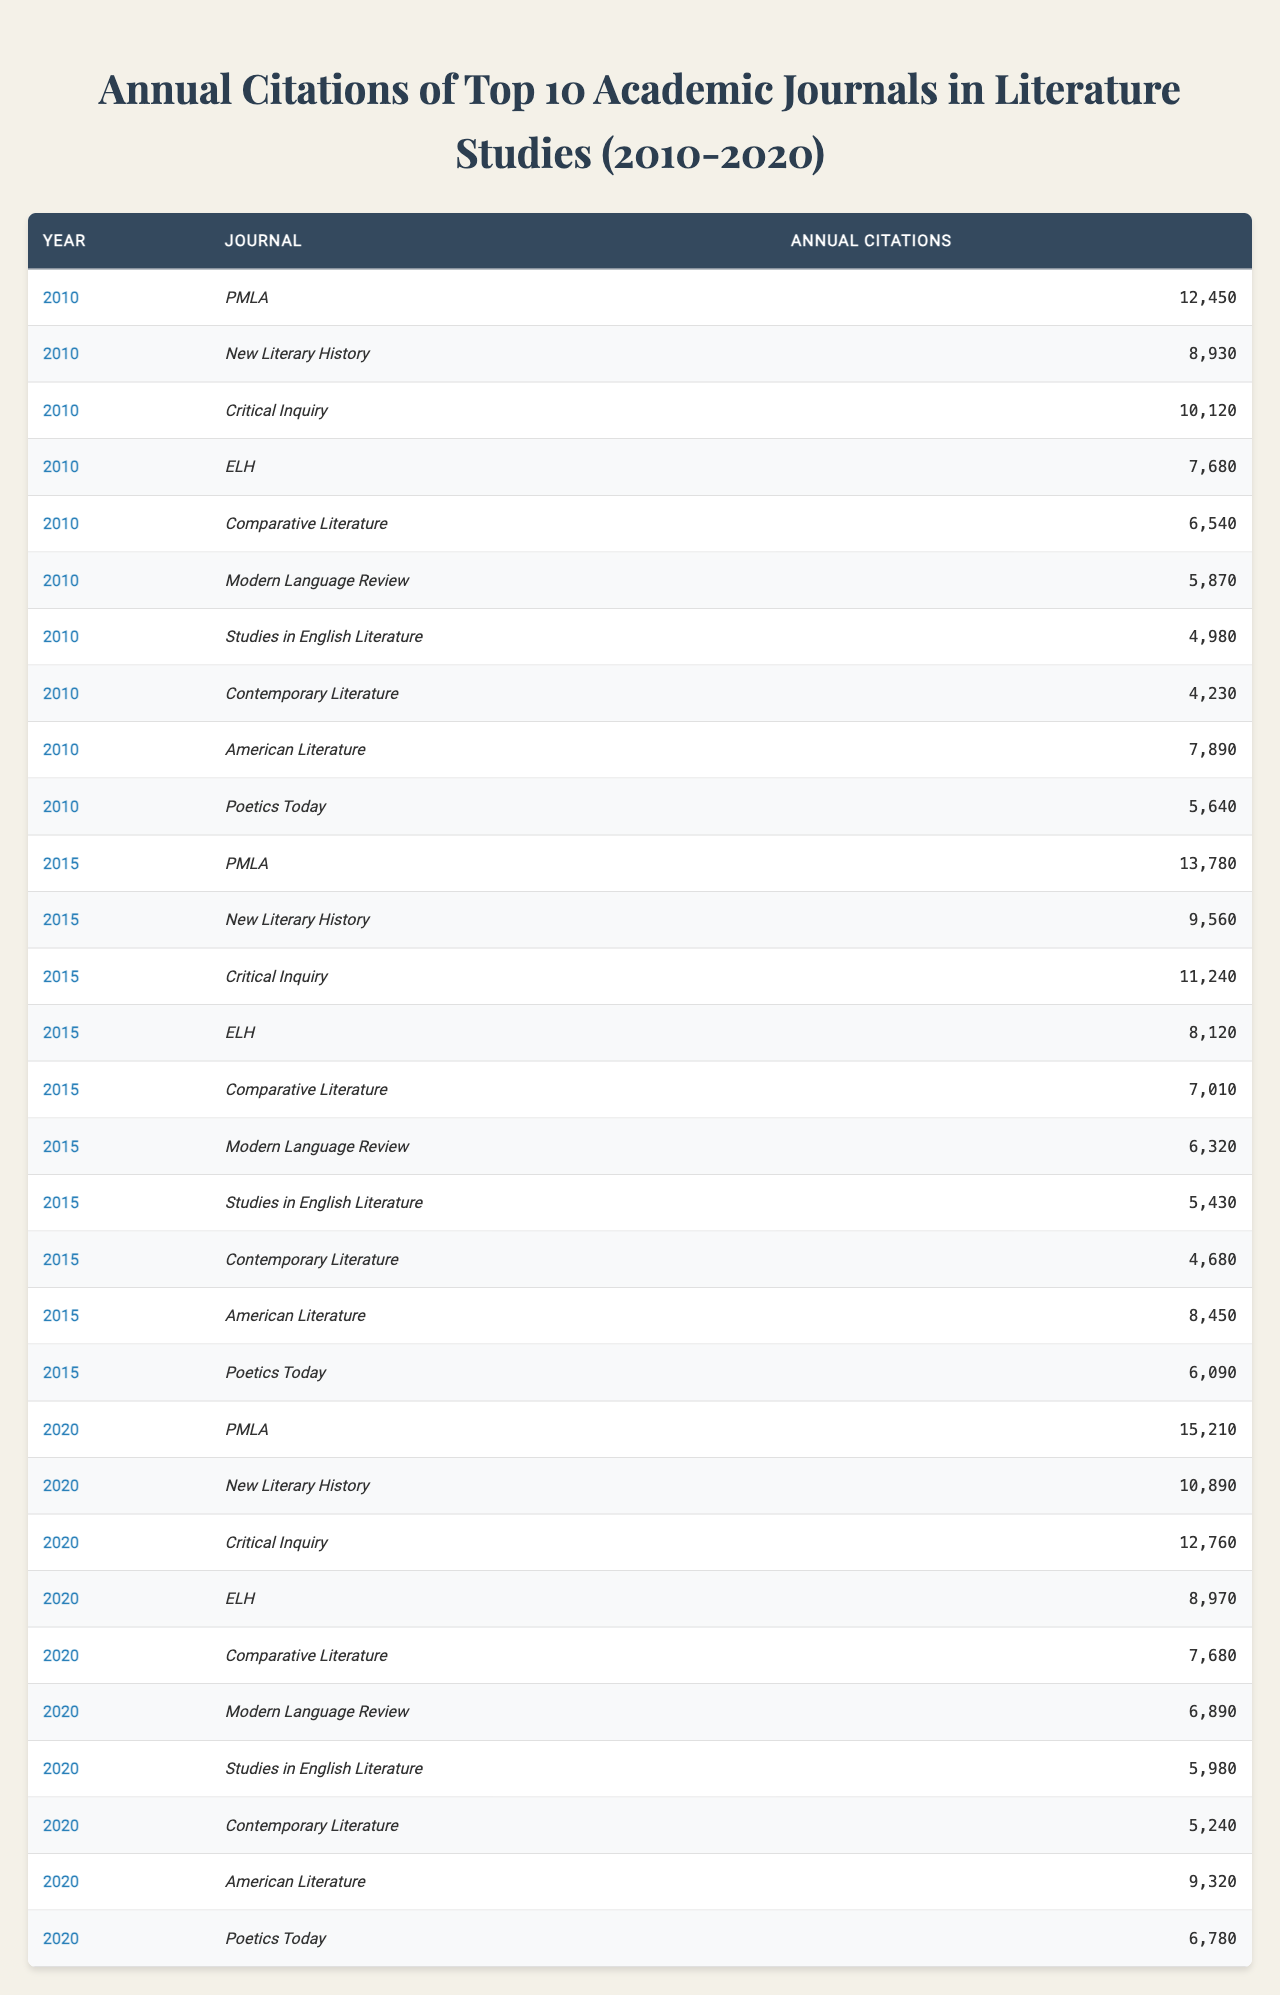What was the highest annual citation for "PMLA" in the years provided? In the years 2010, 2015, and 2020, the citations for "PMLA" were 12450, 13780, and 15210 respectively. The highest citation among these is 15210 in 2020.
Answer: 15210 Which journal had the lowest citations in 2010? Looking at the citations for the journals in 2010, "Contemporary Literature" had the lowest citation count with 4230.
Answer: 4230 What was the average annual citation for "Critical Inquiry" across all three years? The citations for "Critical Inquiry" in the years provided are 10120, 11240, and 12760. Adding these gives 34120, and dividing by 3 gives the average of 11373.33, which rounds to 11373.
Answer: 11373 Did "Modern Language Review" have a constant increase in citations from 2010 to 2020? In 2010, "Modern Language Review" had 5870, in 2015 it was 6320, and in 2020 it was 6890. Each value increases from the previous year, confirming a constant increase.
Answer: Yes Which journal had the biggest jump in annual citations between 2015 and 2020? The citation counts for 2015 and 2020 are compared for each journal. "Critical Inquiry" rose from 11240 in 2015 to 12760 in 2020, resulting in a jump of 1520, which is the largest increase.
Answer: Critical Inquiry What is the total number of citations for "American Literature" across the three years? Summing the citations in 2010 (7890), 2015 (8450), and 2020 (9320) gives a total of 25660 for "American Literature."
Answer: 25660 What proportion of the total citations in 2020 came from "PMLA"? In 2020, total citations across all journals is 63410 (sum of citations). "PMLA" had 15210 citations, so the proportion is 15210 / 63410, approximately 0.2399, or 23.99%.
Answer: 23.99% Was there an increase in citations for "New Literary History" from 2010 to 2020? The citations for "New Literary History" were 8930 in 2010 and rose to 10890 in 2020, indicating an increase.
Answer: Yes What was the difference in citations for "ELH" between 2015 and 2020? The citations for "ELH" were 8120 in 2015 and 8970 in 2020. The difference is 8970 - 8120, which equals 850.
Answer: 850 Which journal had the second highest citations in the year 2015? In 2015, the citations for the journals are as follows: "PMLA" (13780), "Critical Inquiry" (11240). The second highest citations were thus for "Critical Inquiry".
Answer: Critical Inquiry 